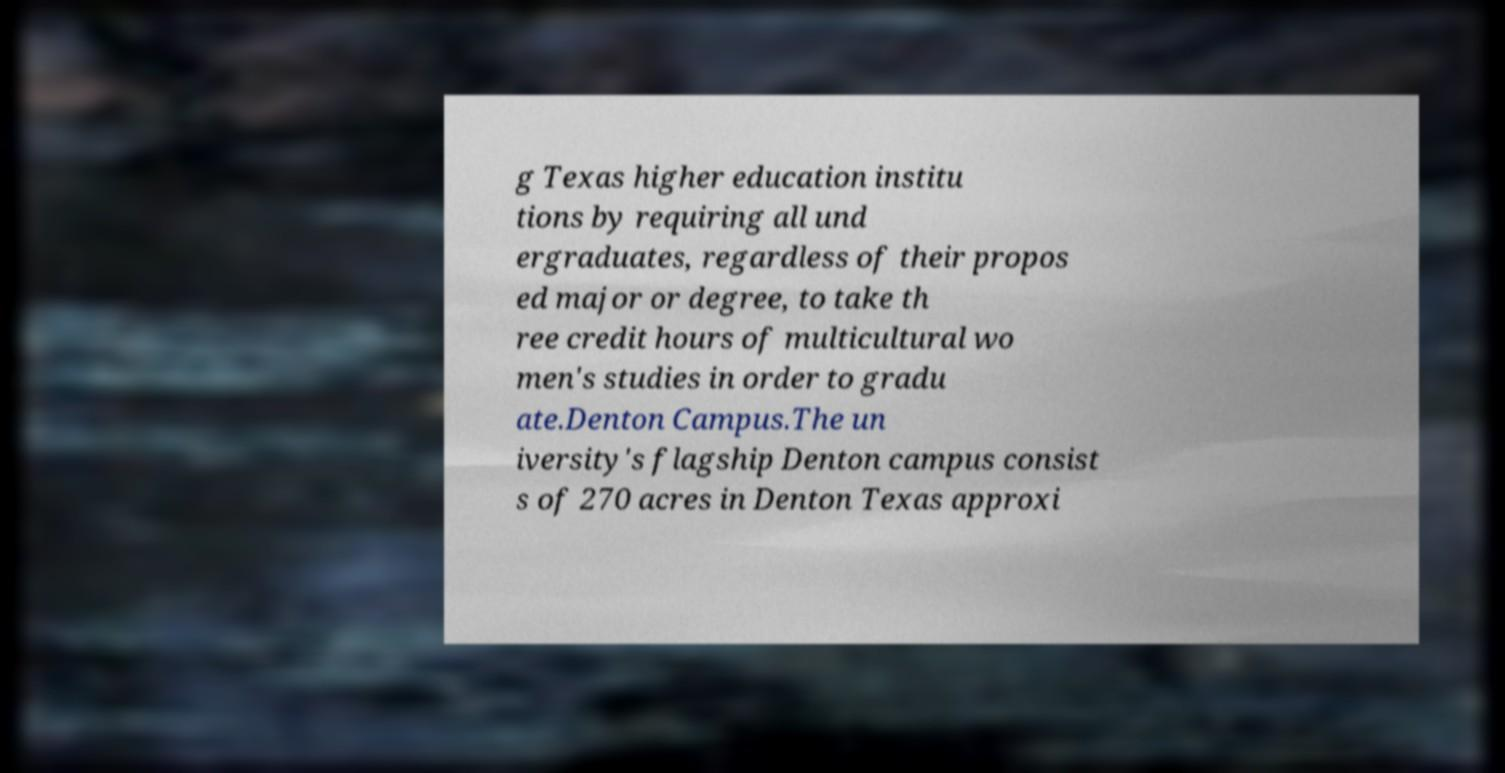Could you extract and type out the text from this image? g Texas higher education institu tions by requiring all und ergraduates, regardless of their propos ed major or degree, to take th ree credit hours of multicultural wo men's studies in order to gradu ate.Denton Campus.The un iversity's flagship Denton campus consist s of 270 acres in Denton Texas approxi 